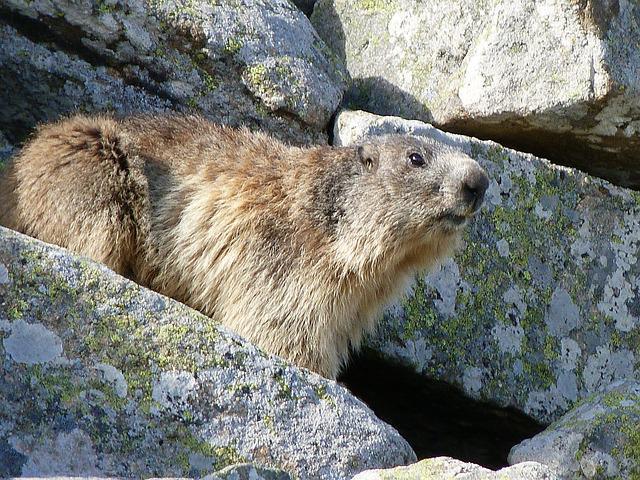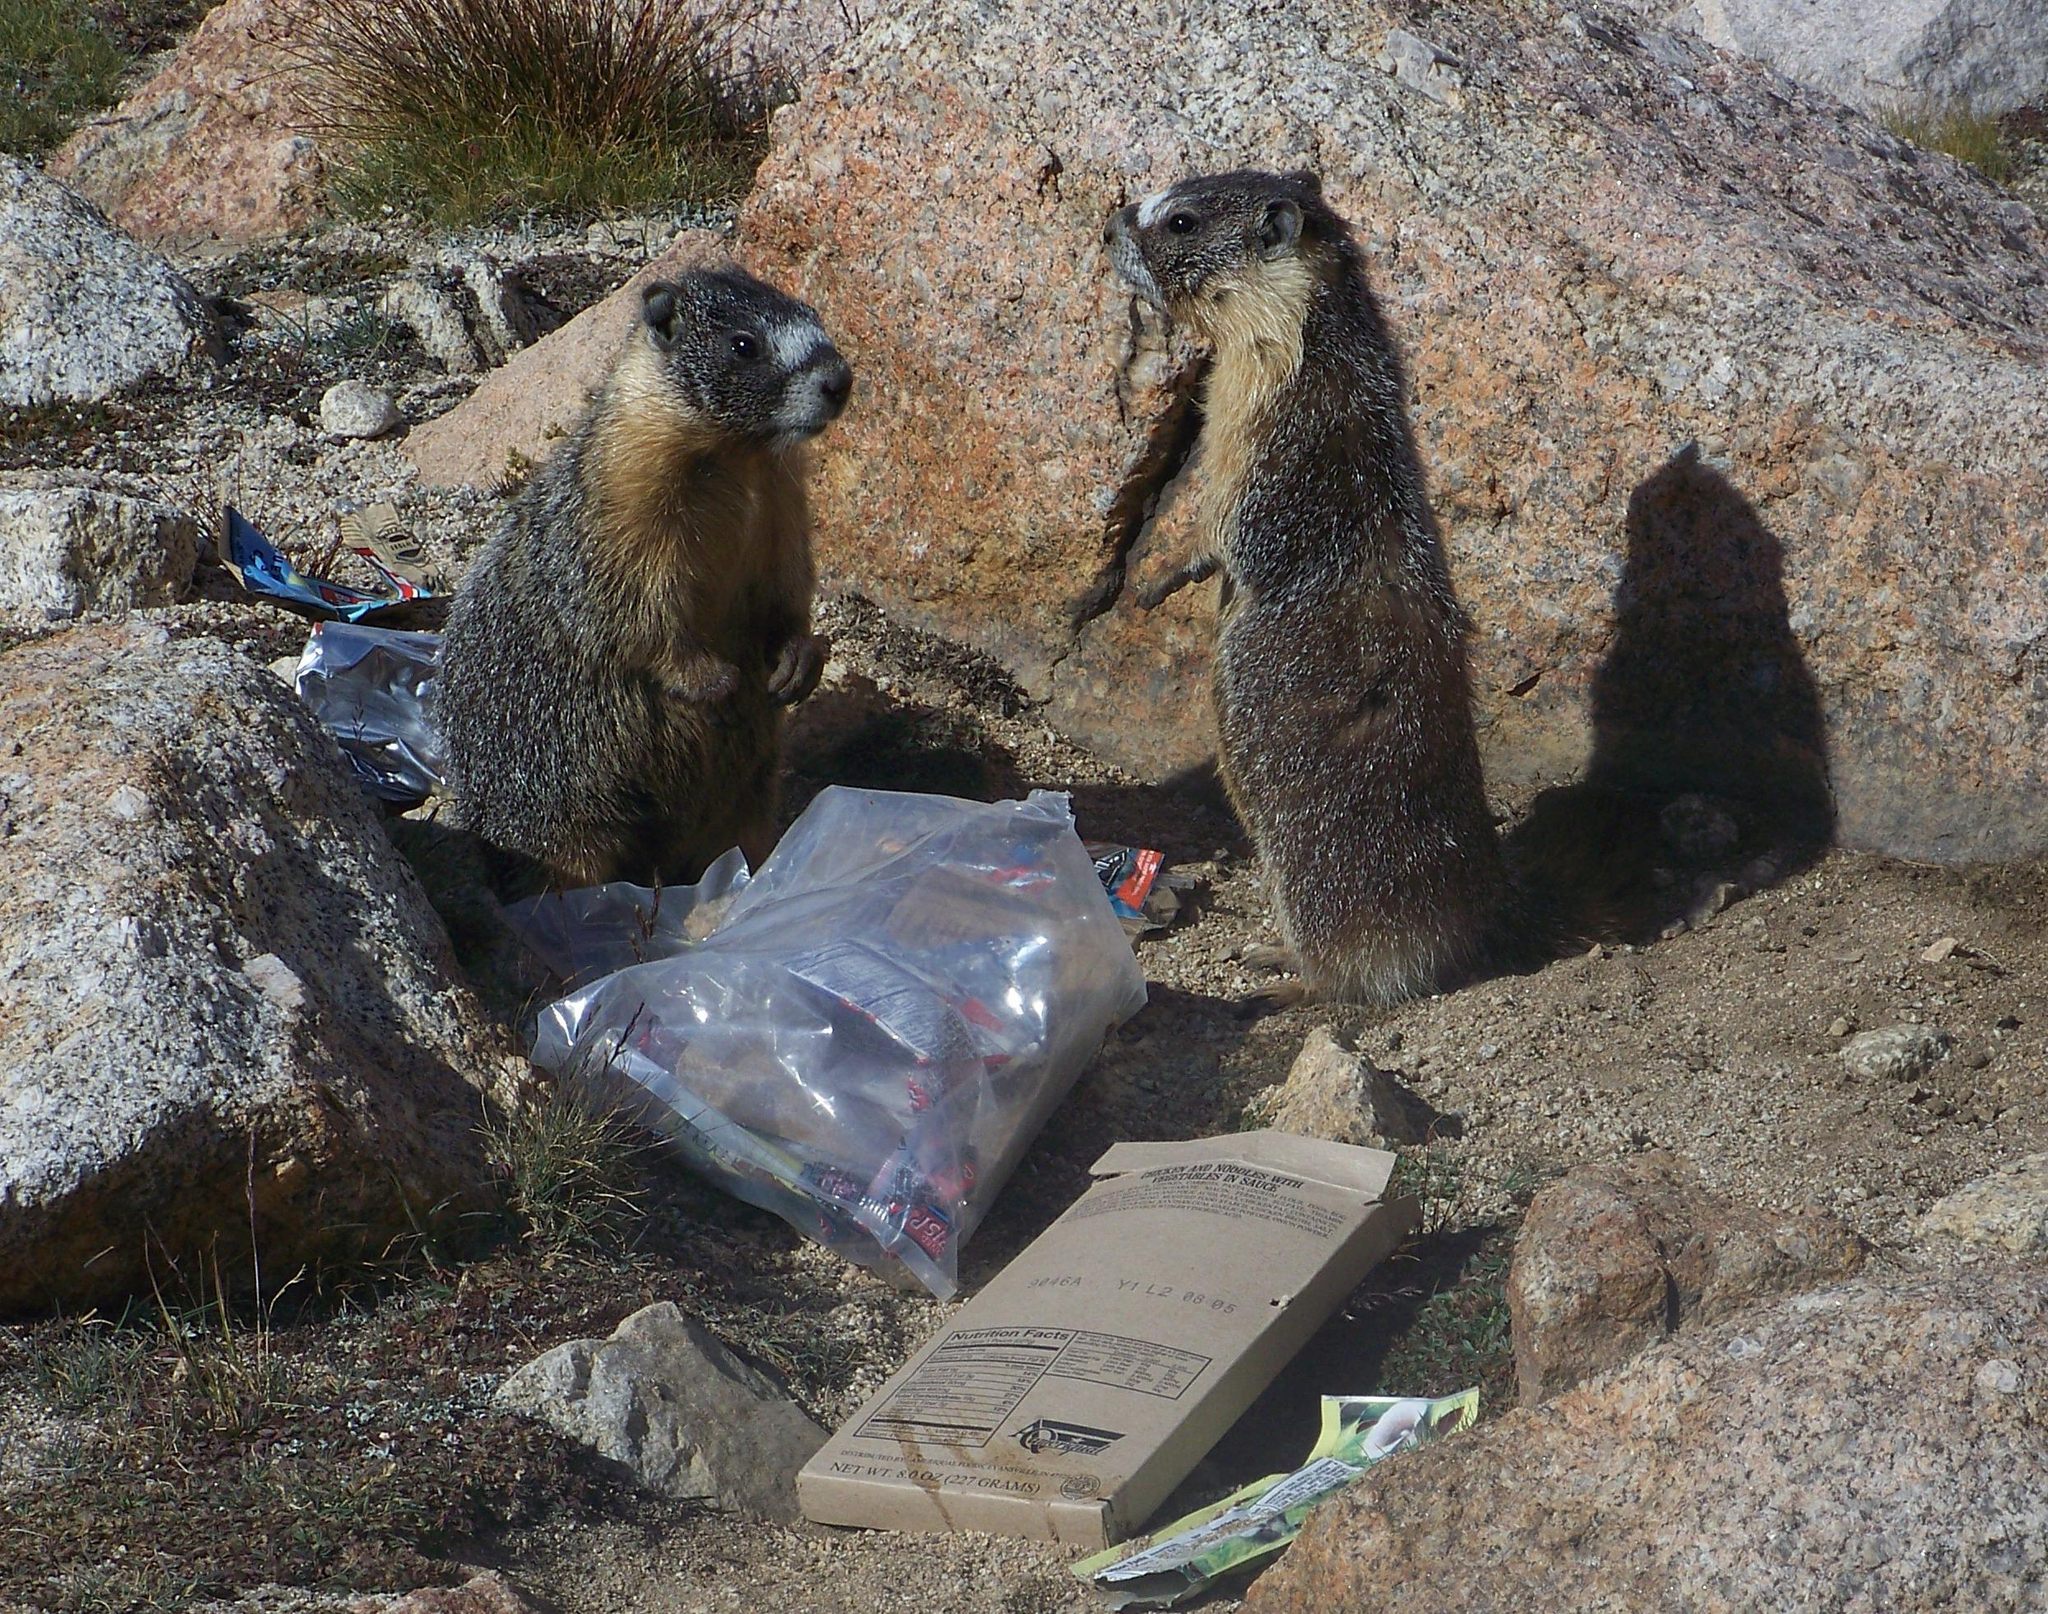The first image is the image on the left, the second image is the image on the right. For the images shown, is this caption "An image shows only one marmot, which is on all fours with body and head facing right." true? Answer yes or no. Yes. The first image is the image on the left, the second image is the image on the right. Examine the images to the left and right. Is the description "The animal in the left image is standing on a boulder." accurate? Answer yes or no. Yes. 